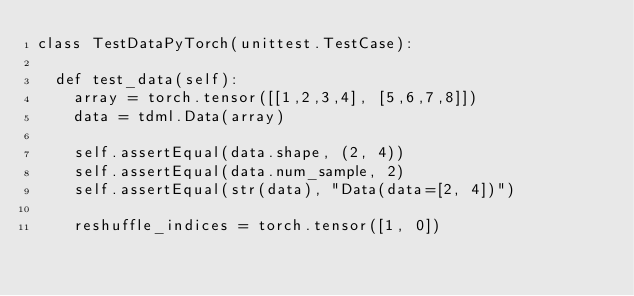Convert code to text. <code><loc_0><loc_0><loc_500><loc_500><_Python_>class TestDataPyTorch(unittest.TestCase):

	def test_data(self):
		array = torch.tensor([[1,2,3,4], [5,6,7,8]])
		data = tdml.Data(array)

		self.assertEqual(data.shape, (2, 4))
		self.assertEqual(data.num_sample, 2)
		self.assertEqual(str(data), "Data(data=[2, 4])")

		reshuffle_indices = torch.tensor([1, 0])</code> 